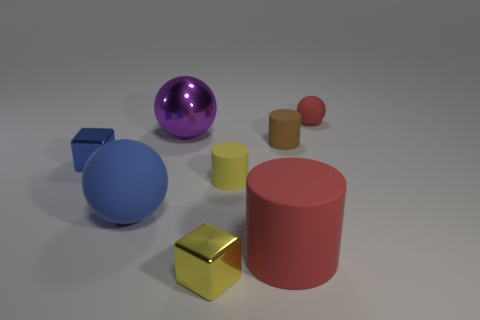There is a thing that is the same color as the large cylinder; what is its material?
Offer a very short reply. Rubber. There is a tiny object that is the same color as the large cylinder; what is its shape?
Offer a very short reply. Sphere. Are there any cylinders of the same color as the large shiny object?
Provide a short and direct response. No. Does the purple shiny thing have the same size as the red matte thing on the left side of the small ball?
Offer a terse response. Yes. How many yellow metallic cubes are on the right side of the shiny block that is to the left of the ball that is in front of the tiny blue metallic cube?
Offer a very short reply. 1. What number of matte cylinders are in front of the blue rubber sphere?
Offer a terse response. 1. The tiny matte cylinder in front of the tiny metal cube left of the small yellow metal object is what color?
Your answer should be compact. Yellow. How many other things are there of the same material as the small red object?
Your answer should be compact. 4. Are there an equal number of blue metal cubes that are in front of the big rubber cylinder and cubes?
Ensure brevity in your answer.  No. There is a cylinder that is on the left side of the cylinder in front of the matte ball in front of the red rubber ball; what is its material?
Give a very brief answer. Rubber. 